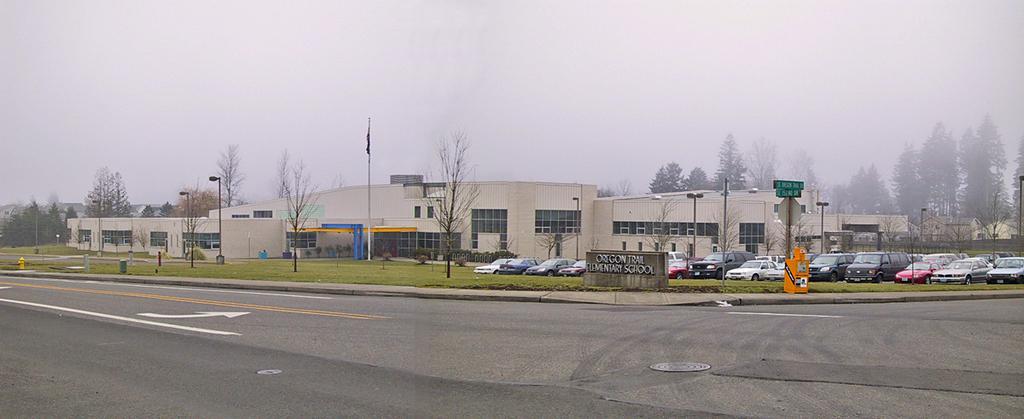Can you describe this image briefly? This image is taken outdoors. At the top of the image there is the sky. At the bottom of the image there is a road. In the background there are a few houses and there are many trees and plants on the ground. In the middle of the image there are a few houses with walls, windows, doors and roofs. There are a few poles with street lights. There is a flag. There is a board with a text on it. There is a text on the wall. Many cars are parked on the ground and there is a ground with grass on it. There is a hydrant on the ground. 